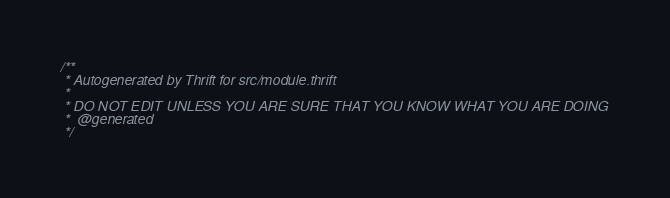<code> <loc_0><loc_0><loc_500><loc_500><_C++_>/**
 * Autogenerated by Thrift for src/module.thrift
 *
 * DO NOT EDIT UNLESS YOU ARE SURE THAT YOU KNOW WHAT YOU ARE DOING
 *  @generated
 */
</code> 